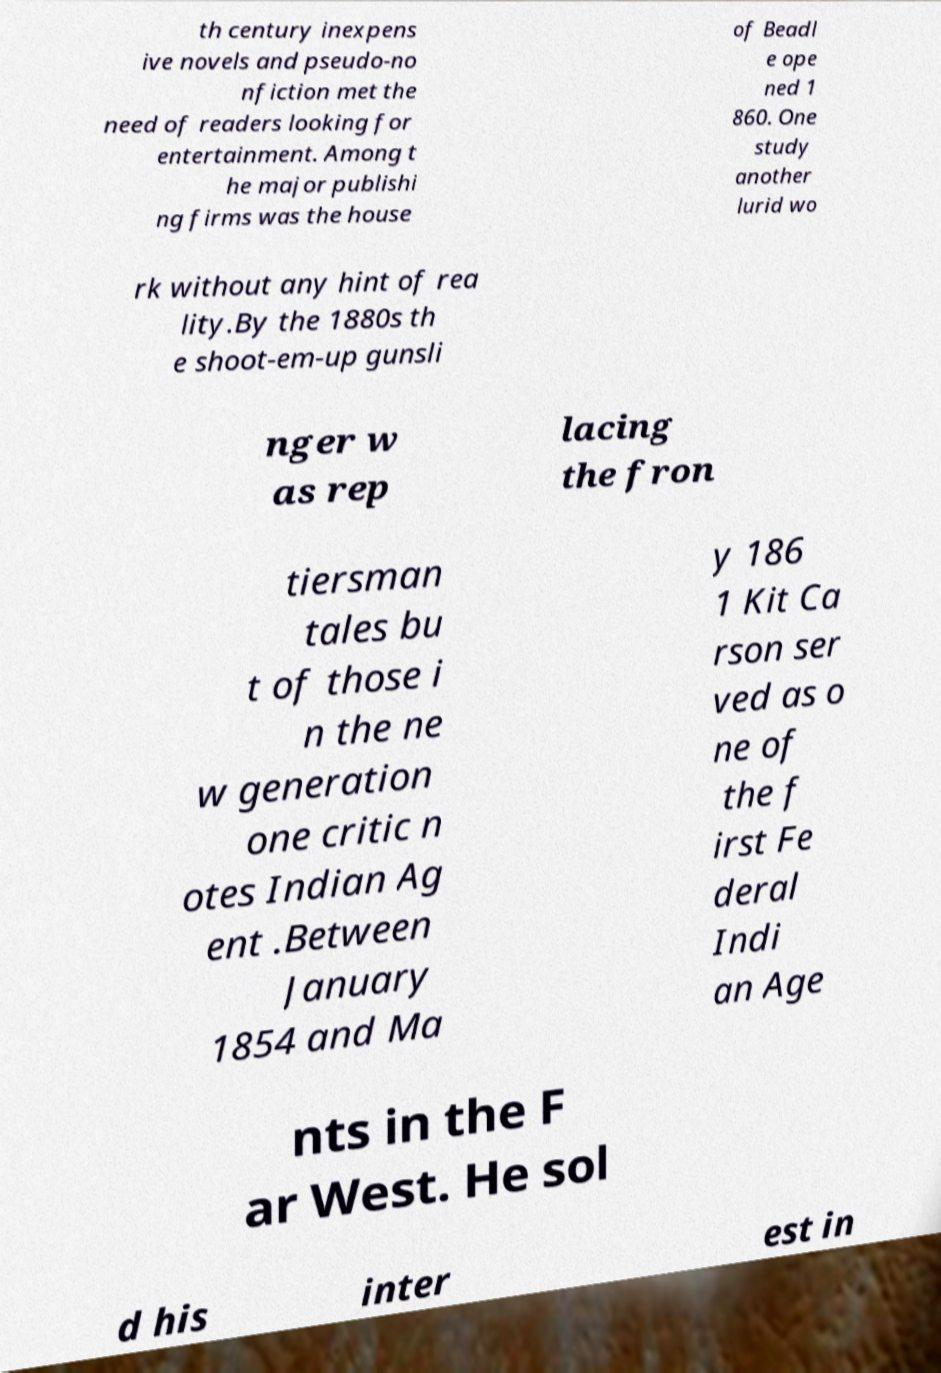Could you extract and type out the text from this image? th century inexpens ive novels and pseudo-no nfiction met the need of readers looking for entertainment. Among t he major publishi ng firms was the house of Beadl e ope ned 1 860. One study another lurid wo rk without any hint of rea lity.By the 1880s th e shoot-em-up gunsli nger w as rep lacing the fron tiersman tales bu t of those i n the ne w generation one critic n otes Indian Ag ent .Between January 1854 and Ma y 186 1 Kit Ca rson ser ved as o ne of the f irst Fe deral Indi an Age nts in the F ar West. He sol d his inter est in 